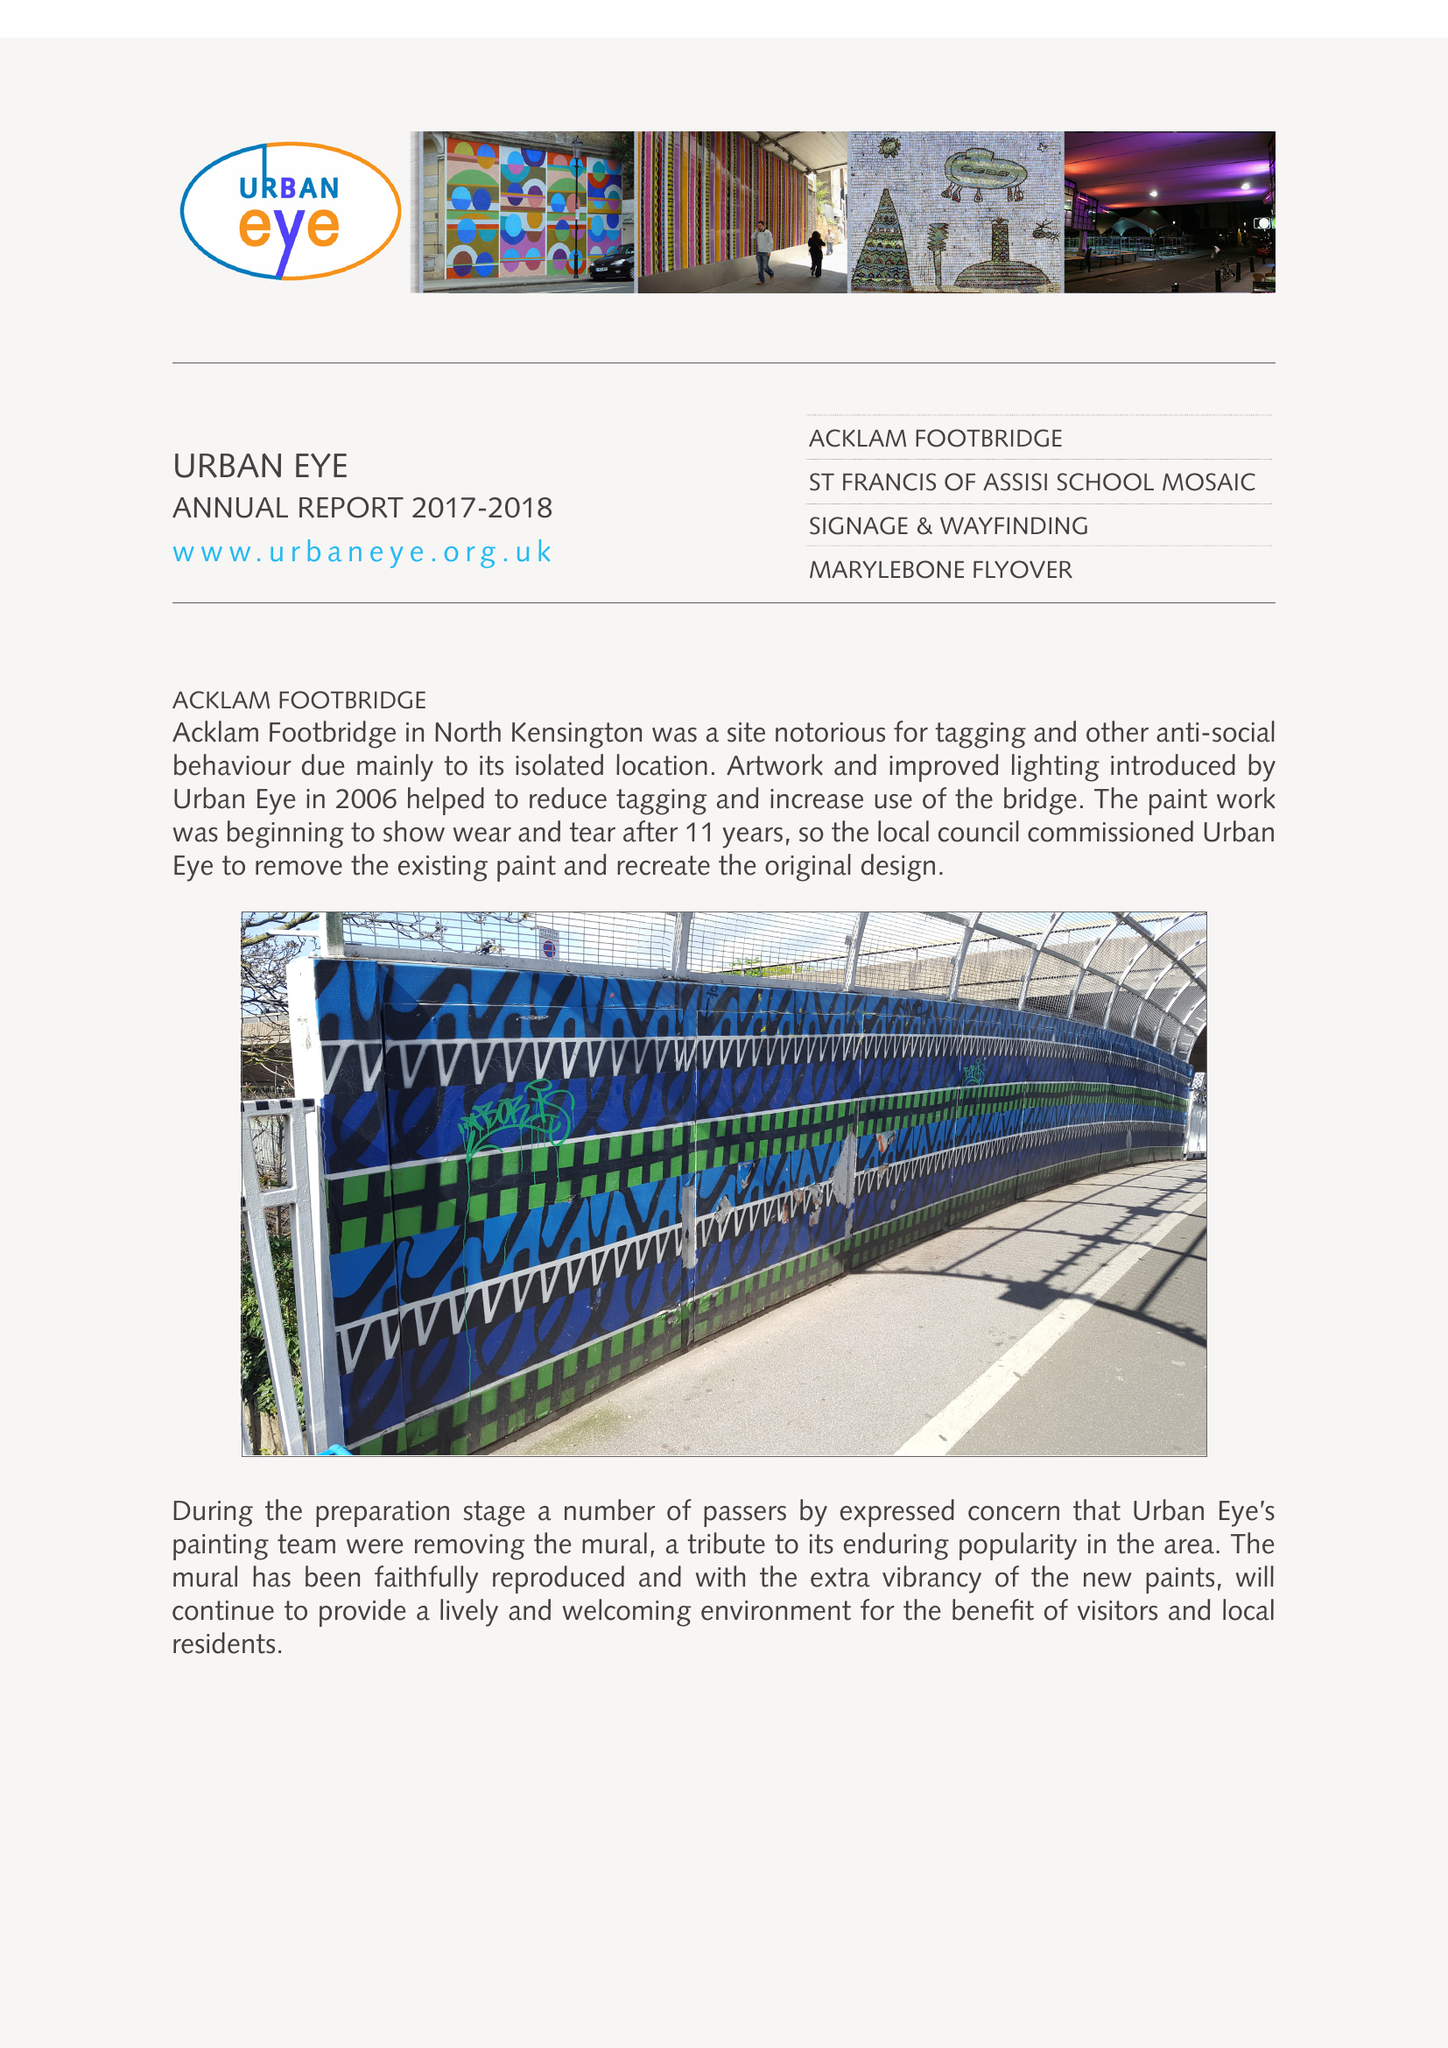What is the value for the report_date?
Answer the question using a single word or phrase. 2018-03-31 